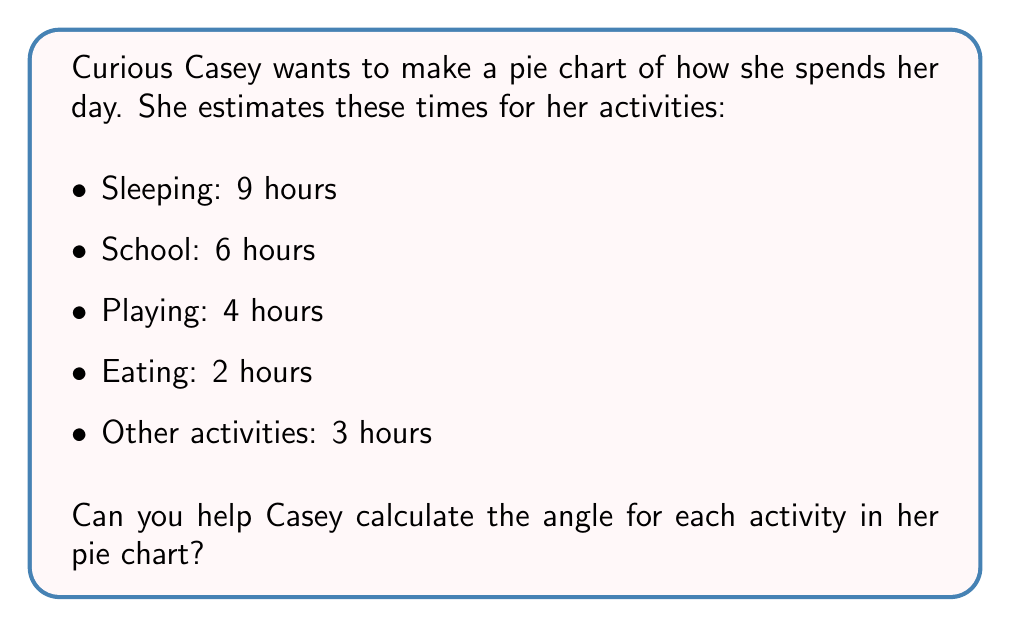Show me your answer to this math problem. Let's solve this step-by-step:

1. First, we need to find the total hours in Casey's day:
   $$ 9 + 6 + 4 + 2 + 3 = 24 \text{ hours} $$

2. In a pie chart, there are 360° in total. We need to find how many degrees each hour represents:
   $$ \frac{360°}{24 \text{ hours}} = 15° \text{ per hour} $$

3. Now, we can calculate the angle for each activity:

   Sleeping: $$ 9 \times 15° = 135° $$
   School: $$ 6 \times 15° = 90° $$
   Playing: $$ 4 \times 15° = 60° $$
   Eating: $$ 2 \times 15° = 30° $$
   Other activities: $$ 3 \times 15° = 45° $$

4. Let's check if all angles add up to 360°:
   $$ 135° + 90° + 60° + 30° + 45° = 360° $$

5. Now we can draw the pie chart:

[asy]
import graph;

size(200);
real[] angles = {135, 90, 60, 30, 45};
string[] labels = {"Sleeping", "School", "Playing", "Eating", "Other"};
pen[] colors = {rgb(0.5,0.8,0.9), rgb(0.9,0.5,0.5), rgb(0.5,0.9,0.5), rgb(0.9,0.9,0.5), rgb(0.8,0.5,0.8)};

real currentAngle = 0;
for(int i = 0; i < angles.length; ++i) {
  fill(arc((0,0), 1, currentAngle, currentAngle + angles[i]), colors[i]);
  label(labels[i], angle(currentAngle + angles[i]/2) * dir(1), dir(currentAngle + angles[i]/2));
  currentAngle += angles[i];
}
[/asy]
Answer: The angles for each activity in Casey's pie chart are:
Sleeping: 135°
School: 90°
Playing: 60°
Eating: 30°
Other activities: 45° 